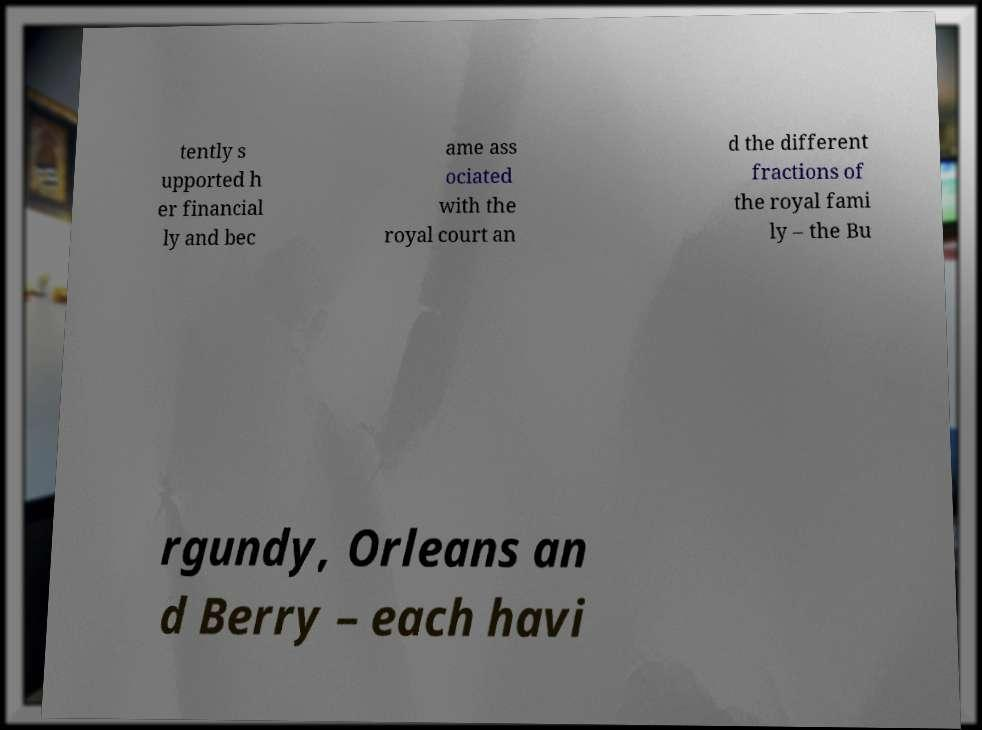Could you assist in decoding the text presented in this image and type it out clearly? tently s upported h er financial ly and bec ame ass ociated with the royal court an d the different fractions of the royal fami ly – the Bu rgundy, Orleans an d Berry – each havi 